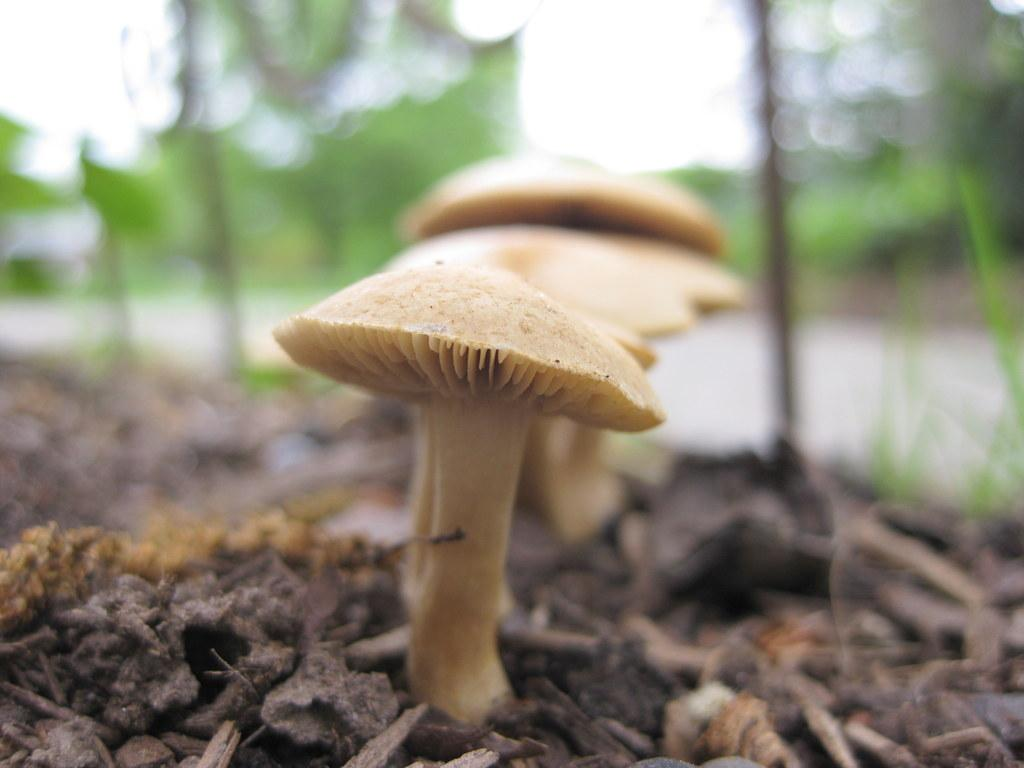What type of fungi can be seen in the image? There are mushrooms present in the image. What type of potato is being cooked in the image? There is no potato present in the image, and no cooking is depicted. What are the mushrooms talking about in the image? Mushrooms do not have the ability to talk, and there is no conversation depicted in the image. 